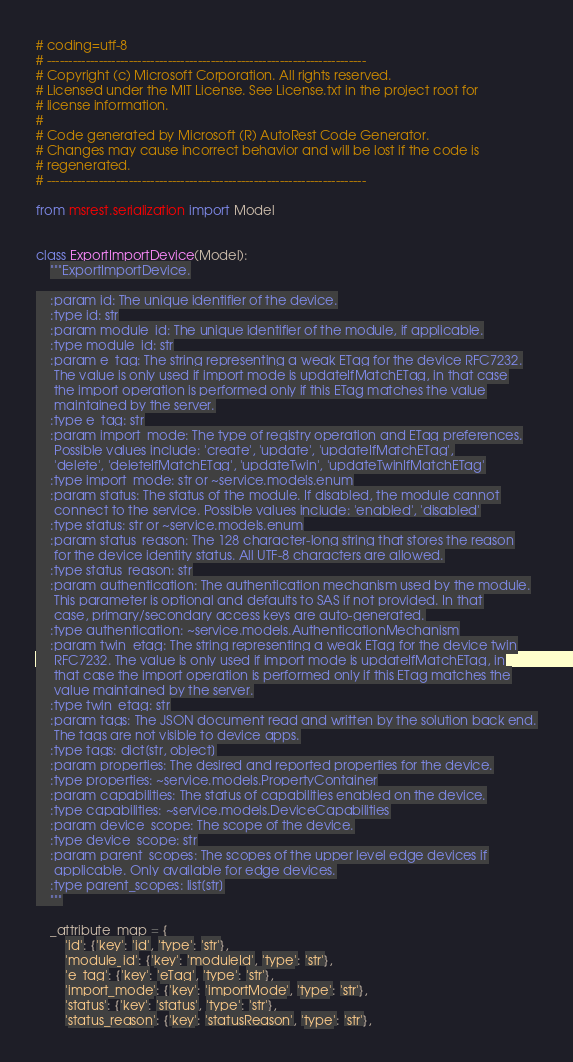<code> <loc_0><loc_0><loc_500><loc_500><_Python_># coding=utf-8
# --------------------------------------------------------------------------
# Copyright (c) Microsoft Corporation. All rights reserved.
# Licensed under the MIT License. See License.txt in the project root for
# license information.
#
# Code generated by Microsoft (R) AutoRest Code Generator.
# Changes may cause incorrect behavior and will be lost if the code is
# regenerated.
# --------------------------------------------------------------------------

from msrest.serialization import Model


class ExportImportDevice(Model):
    """ExportImportDevice.

    :param id: The unique identifier of the device.
    :type id: str
    :param module_id: The unique identifier of the module, if applicable.
    :type module_id: str
    :param e_tag: The string representing a weak ETag for the device RFC7232.
     The value is only used if import mode is updateIfMatchETag, in that case
     the import operation is performed only if this ETag matches the value
     maintained by the server.
    :type e_tag: str
    :param import_mode: The type of registry operation and ETag preferences.
     Possible values include: 'create', 'update', 'updateIfMatchETag',
     'delete', 'deleteIfMatchETag', 'updateTwin', 'updateTwinIfMatchETag'
    :type import_mode: str or ~service.models.enum
    :param status: The status of the module. If disabled, the module cannot
     connect to the service. Possible values include: 'enabled', 'disabled'
    :type status: str or ~service.models.enum
    :param status_reason: The 128 character-long string that stores the reason
     for the device identity status. All UTF-8 characters are allowed.
    :type status_reason: str
    :param authentication: The authentication mechanism used by the module.
     This parameter is optional and defaults to SAS if not provided. In that
     case, primary/secondary access keys are auto-generated.
    :type authentication: ~service.models.AuthenticationMechanism
    :param twin_etag: The string representing a weak ETag for the device twin
     RFC7232. The value is only used if import mode is updateIfMatchETag, in
     that case the import operation is performed only if this ETag matches the
     value maintained by the server.
    :type twin_etag: str
    :param tags: The JSON document read and written by the solution back end.
     The tags are not visible to device apps.
    :type tags: dict[str, object]
    :param properties: The desired and reported properties for the device.
    :type properties: ~service.models.PropertyContainer
    :param capabilities: The status of capabilities enabled on the device.
    :type capabilities: ~service.models.DeviceCapabilities
    :param device_scope: The scope of the device.
    :type device_scope: str
    :param parent_scopes: The scopes of the upper level edge devices if
     applicable. Only available for edge devices.
    :type parent_scopes: list[str]
    """

    _attribute_map = {
        'id': {'key': 'id', 'type': 'str'},
        'module_id': {'key': 'moduleId', 'type': 'str'},
        'e_tag': {'key': 'eTag', 'type': 'str'},
        'import_mode': {'key': 'importMode', 'type': 'str'},
        'status': {'key': 'status', 'type': 'str'},
        'status_reason': {'key': 'statusReason', 'type': 'str'},</code> 